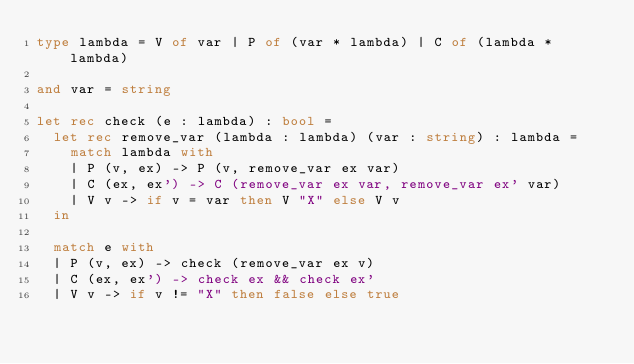Convert code to text. <code><loc_0><loc_0><loc_500><loc_500><_OCaml_>type lambda = V of var | P of (var * lambda) | C of (lambda * lambda)

and var = string

let rec check (e : lambda) : bool =
  let rec remove_var (lambda : lambda) (var : string) : lambda =
    match lambda with
    | P (v, ex) -> P (v, remove_var ex var)
    | C (ex, ex') -> C (remove_var ex var, remove_var ex' var)
    | V v -> if v = var then V "X" else V v
  in

  match e with
  | P (v, ex) -> check (remove_var ex v)
  | C (ex, ex') -> check ex && check ex'
  | V v -> if v != "X" then false else true
</code> 